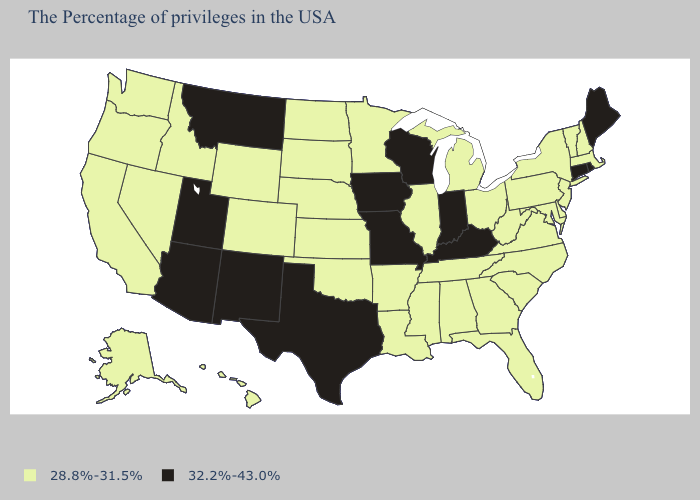Among the states that border Missouri , which have the highest value?
Short answer required. Kentucky, Iowa. What is the lowest value in the USA?
Give a very brief answer. 28.8%-31.5%. What is the value of Vermont?
Write a very short answer. 28.8%-31.5%. What is the value of South Carolina?
Keep it brief. 28.8%-31.5%. Name the states that have a value in the range 32.2%-43.0%?
Give a very brief answer. Maine, Rhode Island, Connecticut, Kentucky, Indiana, Wisconsin, Missouri, Iowa, Texas, New Mexico, Utah, Montana, Arizona. Does New Hampshire have a lower value than Indiana?
Answer briefly. Yes. Name the states that have a value in the range 32.2%-43.0%?
Be succinct. Maine, Rhode Island, Connecticut, Kentucky, Indiana, Wisconsin, Missouri, Iowa, Texas, New Mexico, Utah, Montana, Arizona. What is the value of West Virginia?
Write a very short answer. 28.8%-31.5%. What is the value of West Virginia?
Give a very brief answer. 28.8%-31.5%. Which states hav the highest value in the West?
Write a very short answer. New Mexico, Utah, Montana, Arizona. Does the first symbol in the legend represent the smallest category?
Quick response, please. Yes. What is the highest value in states that border Illinois?
Give a very brief answer. 32.2%-43.0%. Does Wyoming have the lowest value in the West?
Keep it brief. Yes. Name the states that have a value in the range 28.8%-31.5%?
Keep it brief. Massachusetts, New Hampshire, Vermont, New York, New Jersey, Delaware, Maryland, Pennsylvania, Virginia, North Carolina, South Carolina, West Virginia, Ohio, Florida, Georgia, Michigan, Alabama, Tennessee, Illinois, Mississippi, Louisiana, Arkansas, Minnesota, Kansas, Nebraska, Oklahoma, South Dakota, North Dakota, Wyoming, Colorado, Idaho, Nevada, California, Washington, Oregon, Alaska, Hawaii. Which states have the highest value in the USA?
Keep it brief. Maine, Rhode Island, Connecticut, Kentucky, Indiana, Wisconsin, Missouri, Iowa, Texas, New Mexico, Utah, Montana, Arizona. 